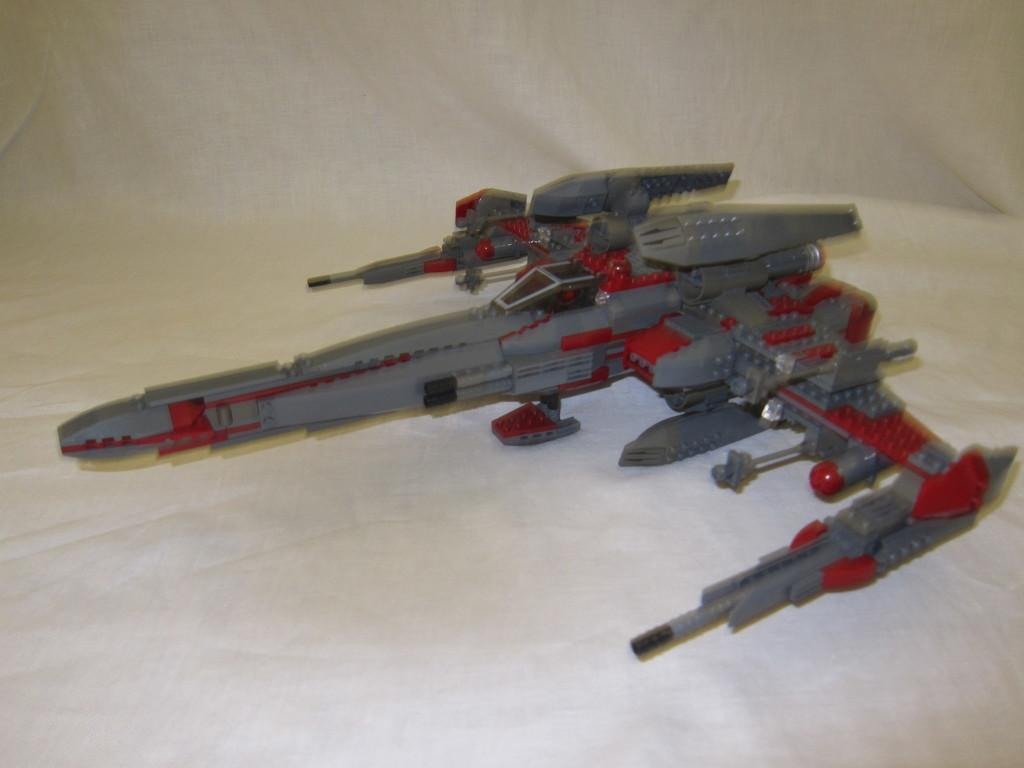What type of aircraft is depicted in the image? There is an artificial aircraft in the image. What color is the cloth at the bottom of the image? The cloth at the bottom of the image is white. Can you tell me how many robins are sitting on the artificial aircraft in the image? There are no robins present in the image; it only features an artificial aircraft and a white cloth. 